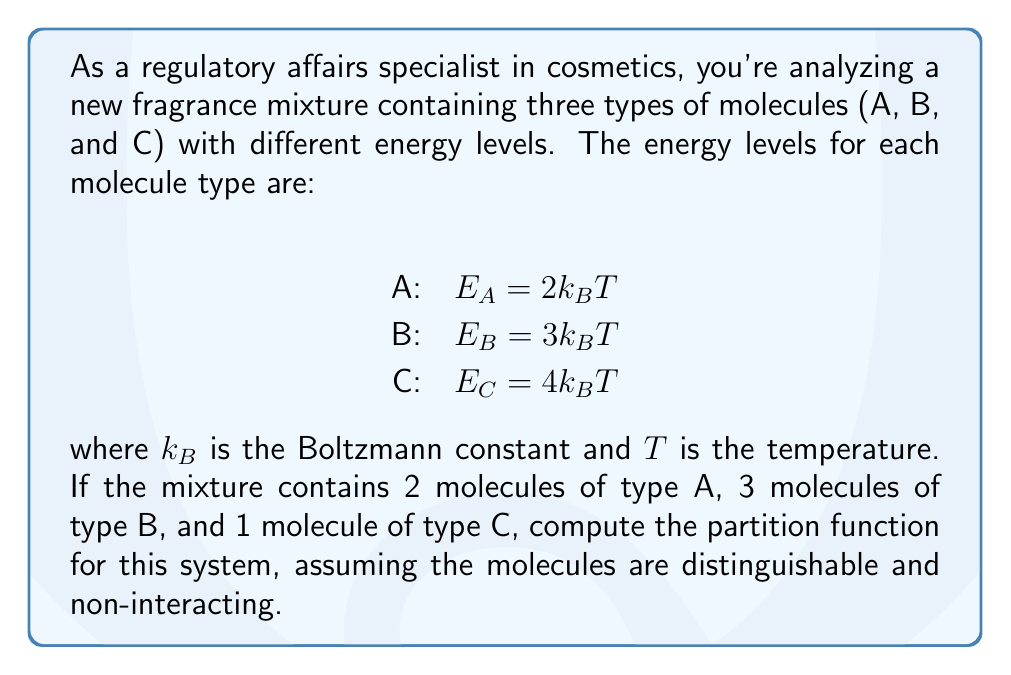Show me your answer to this math problem. To solve this problem, we'll follow these steps:

1) The partition function for a system of distinguishable, non-interacting particles is given by:

   $$Z = \prod_i z_i^{N_i}$$

   where $z_i$ is the partition function for a single particle of type $i$, and $N_i$ is the number of particles of type $i$.

2) For a single particle with energy $E$, the partition function is:

   $$z = e^{-E/k_BT}$$

3) Let's calculate the partition function for each type of molecule:

   For A: $z_A = e^{-E_A/k_BT} = e^{-2} = 0.1353$
   For B: $z_B = e^{-E_B/k_BT} = e^{-3} = 0.0498$
   For C: $z_C = e^{-E_C/k_BT} = e^{-4} = 0.0183$

4) Now, we can plug these values into the partition function formula:

   $$Z = (z_A)^2 \cdot (z_B)^3 \cdot (z_C)^1$$

5) Substituting the values:

   $$Z = (0.1353)^2 \cdot (0.0498)^3 \cdot (0.0183)^1$$

6) Calculate the final result:

   $$Z = 0.0183 \cdot 0.0498^3 \cdot 0.1353^2 = 1.3627 \times 10^{-7}$$
Answer: $1.3627 \times 10^{-7}$ 